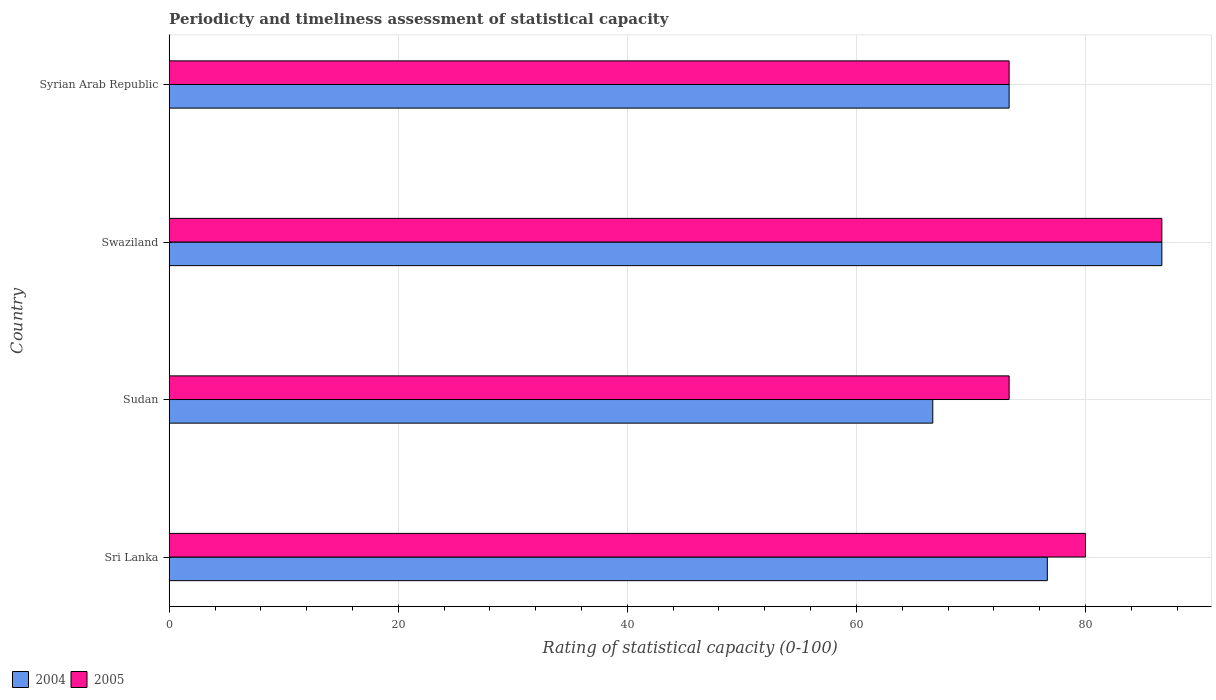How many groups of bars are there?
Your answer should be compact. 4. Are the number of bars per tick equal to the number of legend labels?
Your answer should be compact. Yes. What is the label of the 2nd group of bars from the top?
Keep it short and to the point. Swaziland. What is the rating of statistical capacity in 2004 in Sri Lanka?
Your response must be concise. 76.67. Across all countries, what is the maximum rating of statistical capacity in 2004?
Make the answer very short. 86.67. Across all countries, what is the minimum rating of statistical capacity in 2005?
Your response must be concise. 73.33. In which country was the rating of statistical capacity in 2005 maximum?
Keep it short and to the point. Swaziland. In which country was the rating of statistical capacity in 2005 minimum?
Offer a very short reply. Sudan. What is the total rating of statistical capacity in 2005 in the graph?
Your answer should be very brief. 313.33. What is the difference between the rating of statistical capacity in 2005 in Sri Lanka and that in Sudan?
Ensure brevity in your answer.  6.67. What is the difference between the rating of statistical capacity in 2005 in Sri Lanka and the rating of statistical capacity in 2004 in Sudan?
Provide a succinct answer. 13.33. What is the average rating of statistical capacity in 2005 per country?
Ensure brevity in your answer.  78.33. What is the difference between the rating of statistical capacity in 2005 and rating of statistical capacity in 2004 in Sri Lanka?
Offer a terse response. 3.33. In how many countries, is the rating of statistical capacity in 2004 greater than 80 ?
Make the answer very short. 1. What is the ratio of the rating of statistical capacity in 2005 in Sri Lanka to that in Swaziland?
Your answer should be very brief. 0.92. Is the rating of statistical capacity in 2004 in Sri Lanka less than that in Syrian Arab Republic?
Provide a succinct answer. No. What is the difference between the highest and the second highest rating of statistical capacity in 2004?
Your answer should be very brief. 10. What is the difference between the highest and the lowest rating of statistical capacity in 2005?
Offer a terse response. 13.33. Is the sum of the rating of statistical capacity in 2005 in Sri Lanka and Swaziland greater than the maximum rating of statistical capacity in 2004 across all countries?
Make the answer very short. Yes. Are all the bars in the graph horizontal?
Ensure brevity in your answer.  Yes. What is the difference between two consecutive major ticks on the X-axis?
Provide a short and direct response. 20. Are the values on the major ticks of X-axis written in scientific E-notation?
Provide a short and direct response. No. Where does the legend appear in the graph?
Your answer should be very brief. Bottom left. How are the legend labels stacked?
Give a very brief answer. Horizontal. What is the title of the graph?
Provide a short and direct response. Periodicty and timeliness assessment of statistical capacity. Does "1983" appear as one of the legend labels in the graph?
Provide a succinct answer. No. What is the label or title of the X-axis?
Ensure brevity in your answer.  Rating of statistical capacity (0-100). What is the label or title of the Y-axis?
Your response must be concise. Country. What is the Rating of statistical capacity (0-100) in 2004 in Sri Lanka?
Offer a terse response. 76.67. What is the Rating of statistical capacity (0-100) in 2004 in Sudan?
Offer a terse response. 66.67. What is the Rating of statistical capacity (0-100) of 2005 in Sudan?
Make the answer very short. 73.33. What is the Rating of statistical capacity (0-100) in 2004 in Swaziland?
Provide a succinct answer. 86.67. What is the Rating of statistical capacity (0-100) of 2005 in Swaziland?
Your response must be concise. 86.67. What is the Rating of statistical capacity (0-100) of 2004 in Syrian Arab Republic?
Offer a terse response. 73.33. What is the Rating of statistical capacity (0-100) in 2005 in Syrian Arab Republic?
Offer a very short reply. 73.33. Across all countries, what is the maximum Rating of statistical capacity (0-100) in 2004?
Provide a succinct answer. 86.67. Across all countries, what is the maximum Rating of statistical capacity (0-100) of 2005?
Provide a short and direct response. 86.67. Across all countries, what is the minimum Rating of statistical capacity (0-100) of 2004?
Give a very brief answer. 66.67. Across all countries, what is the minimum Rating of statistical capacity (0-100) of 2005?
Give a very brief answer. 73.33. What is the total Rating of statistical capacity (0-100) in 2004 in the graph?
Provide a short and direct response. 303.33. What is the total Rating of statistical capacity (0-100) in 2005 in the graph?
Your answer should be very brief. 313.33. What is the difference between the Rating of statistical capacity (0-100) in 2004 in Sri Lanka and that in Swaziland?
Provide a short and direct response. -10. What is the difference between the Rating of statistical capacity (0-100) in 2005 in Sri Lanka and that in Swaziland?
Ensure brevity in your answer.  -6.67. What is the difference between the Rating of statistical capacity (0-100) in 2004 in Sri Lanka and that in Syrian Arab Republic?
Offer a terse response. 3.33. What is the difference between the Rating of statistical capacity (0-100) in 2005 in Sri Lanka and that in Syrian Arab Republic?
Make the answer very short. 6.67. What is the difference between the Rating of statistical capacity (0-100) in 2004 in Sudan and that in Swaziland?
Offer a very short reply. -20. What is the difference between the Rating of statistical capacity (0-100) in 2005 in Sudan and that in Swaziland?
Offer a terse response. -13.33. What is the difference between the Rating of statistical capacity (0-100) in 2004 in Sudan and that in Syrian Arab Republic?
Your answer should be compact. -6.67. What is the difference between the Rating of statistical capacity (0-100) of 2005 in Sudan and that in Syrian Arab Republic?
Ensure brevity in your answer.  0. What is the difference between the Rating of statistical capacity (0-100) in 2004 in Swaziland and that in Syrian Arab Republic?
Your response must be concise. 13.33. What is the difference between the Rating of statistical capacity (0-100) of 2005 in Swaziland and that in Syrian Arab Republic?
Make the answer very short. 13.33. What is the difference between the Rating of statistical capacity (0-100) of 2004 in Sri Lanka and the Rating of statistical capacity (0-100) of 2005 in Syrian Arab Republic?
Offer a terse response. 3.33. What is the difference between the Rating of statistical capacity (0-100) in 2004 in Sudan and the Rating of statistical capacity (0-100) in 2005 in Swaziland?
Your answer should be very brief. -20. What is the difference between the Rating of statistical capacity (0-100) in 2004 in Sudan and the Rating of statistical capacity (0-100) in 2005 in Syrian Arab Republic?
Provide a short and direct response. -6.67. What is the difference between the Rating of statistical capacity (0-100) of 2004 in Swaziland and the Rating of statistical capacity (0-100) of 2005 in Syrian Arab Republic?
Ensure brevity in your answer.  13.33. What is the average Rating of statistical capacity (0-100) of 2004 per country?
Provide a succinct answer. 75.83. What is the average Rating of statistical capacity (0-100) in 2005 per country?
Ensure brevity in your answer.  78.33. What is the difference between the Rating of statistical capacity (0-100) of 2004 and Rating of statistical capacity (0-100) of 2005 in Sri Lanka?
Ensure brevity in your answer.  -3.33. What is the difference between the Rating of statistical capacity (0-100) of 2004 and Rating of statistical capacity (0-100) of 2005 in Sudan?
Ensure brevity in your answer.  -6.67. What is the difference between the Rating of statistical capacity (0-100) of 2004 and Rating of statistical capacity (0-100) of 2005 in Syrian Arab Republic?
Keep it short and to the point. 0. What is the ratio of the Rating of statistical capacity (0-100) in 2004 in Sri Lanka to that in Sudan?
Your response must be concise. 1.15. What is the ratio of the Rating of statistical capacity (0-100) in 2005 in Sri Lanka to that in Sudan?
Your response must be concise. 1.09. What is the ratio of the Rating of statistical capacity (0-100) in 2004 in Sri Lanka to that in Swaziland?
Give a very brief answer. 0.88. What is the ratio of the Rating of statistical capacity (0-100) of 2004 in Sri Lanka to that in Syrian Arab Republic?
Give a very brief answer. 1.05. What is the ratio of the Rating of statistical capacity (0-100) of 2005 in Sri Lanka to that in Syrian Arab Republic?
Your response must be concise. 1.09. What is the ratio of the Rating of statistical capacity (0-100) in 2004 in Sudan to that in Swaziland?
Provide a succinct answer. 0.77. What is the ratio of the Rating of statistical capacity (0-100) in 2005 in Sudan to that in Swaziland?
Keep it short and to the point. 0.85. What is the ratio of the Rating of statistical capacity (0-100) in 2004 in Sudan to that in Syrian Arab Republic?
Your answer should be very brief. 0.91. What is the ratio of the Rating of statistical capacity (0-100) of 2005 in Sudan to that in Syrian Arab Republic?
Provide a succinct answer. 1. What is the ratio of the Rating of statistical capacity (0-100) of 2004 in Swaziland to that in Syrian Arab Republic?
Make the answer very short. 1.18. What is the ratio of the Rating of statistical capacity (0-100) in 2005 in Swaziland to that in Syrian Arab Republic?
Make the answer very short. 1.18. What is the difference between the highest and the lowest Rating of statistical capacity (0-100) in 2004?
Your response must be concise. 20. What is the difference between the highest and the lowest Rating of statistical capacity (0-100) in 2005?
Ensure brevity in your answer.  13.33. 